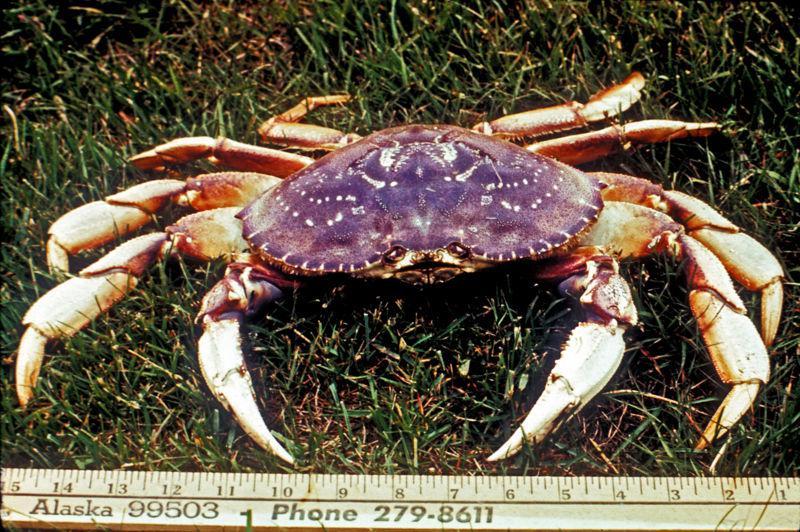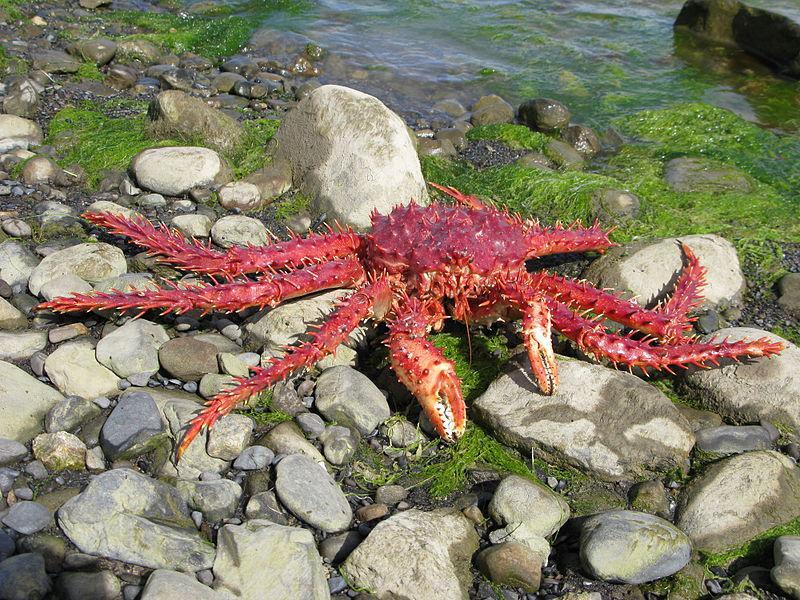The first image is the image on the left, the second image is the image on the right. Evaluate the accuracy of this statement regarding the images: "An image shows a ruler displayed horizontally under a crab facing forward.". Is it true? Answer yes or no. Yes. The first image is the image on the left, the second image is the image on the right. For the images shown, is this caption "There are exactly two crabs." true? Answer yes or no. Yes. 